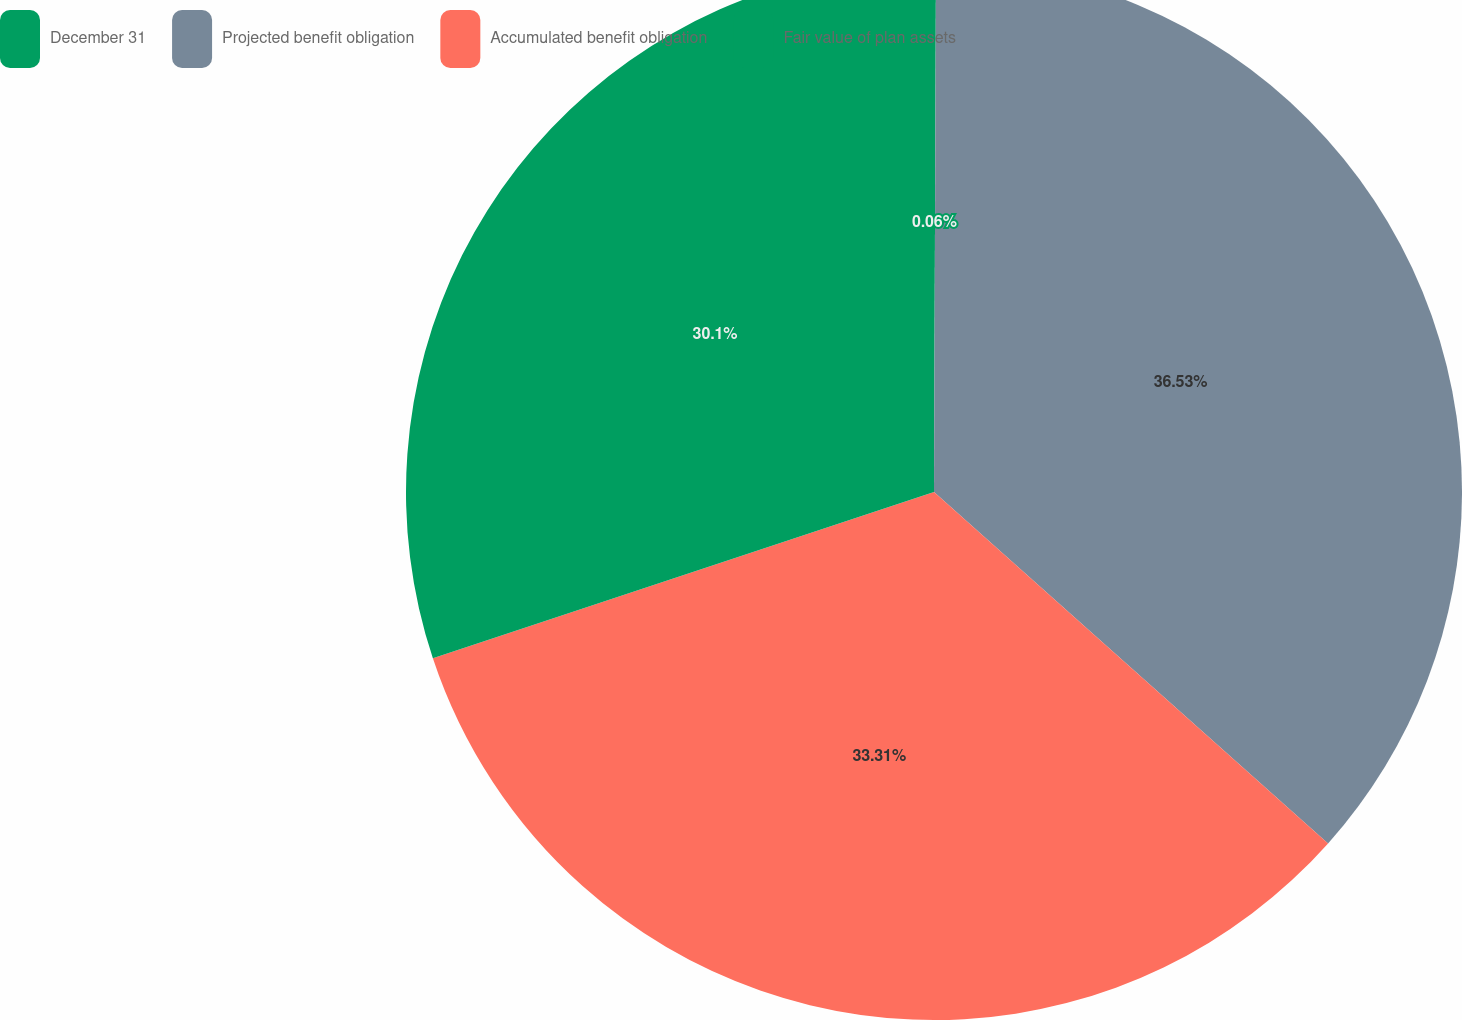Convert chart. <chart><loc_0><loc_0><loc_500><loc_500><pie_chart><fcel>December 31<fcel>Projected benefit obligation<fcel>Accumulated benefit obligation<fcel>Fair value of plan assets<nl><fcel>0.06%<fcel>36.53%<fcel>33.31%<fcel>30.1%<nl></chart> 